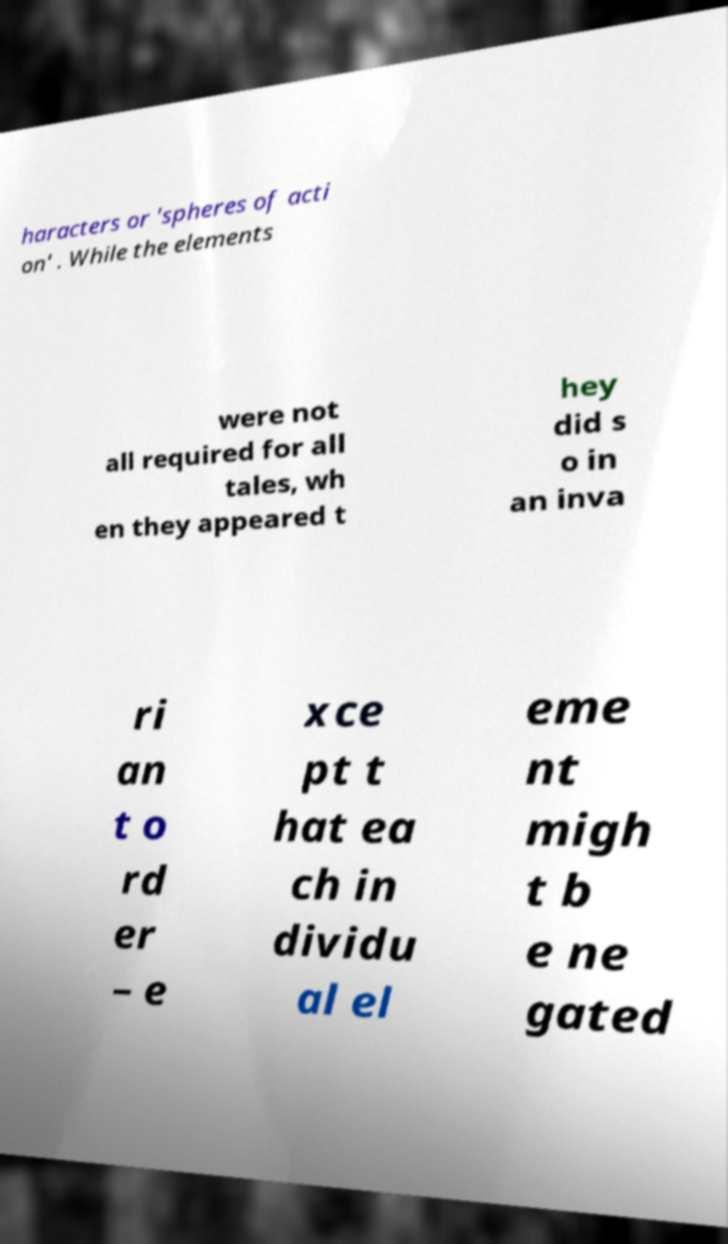Can you accurately transcribe the text from the provided image for me? haracters or 'spheres of acti on' . While the elements were not all required for all tales, wh en they appeared t hey did s o in an inva ri an t o rd er – e xce pt t hat ea ch in dividu al el eme nt migh t b e ne gated 